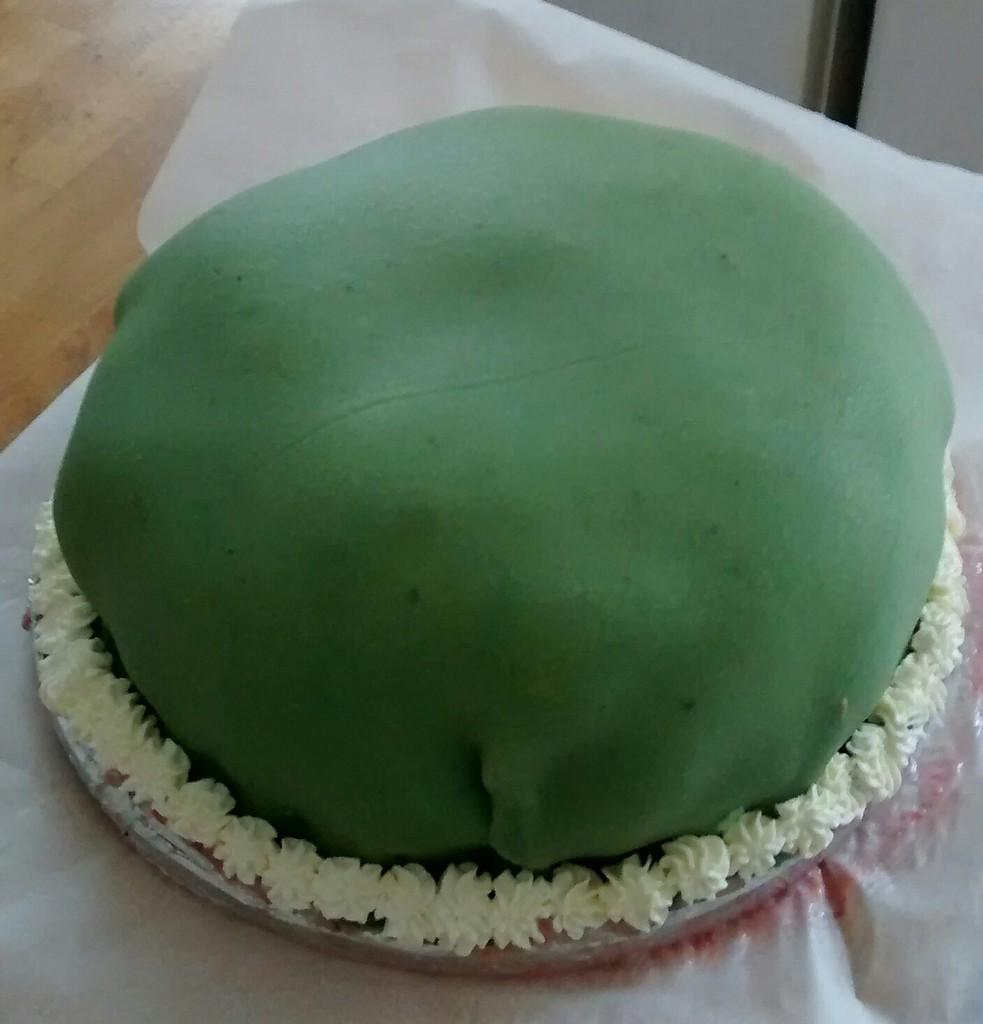What is the color of the object that stands out in the image? There is a green color object in the image. What else can be seen in the image besides the green object? There are other objects in the image. On what surface are the objects placed? The objects are on a white color cloth. How many geese are present in the image? There are no geese present in the image. What does the mom say about the objects in the image? There is no mom or any dialogue present in the image. 